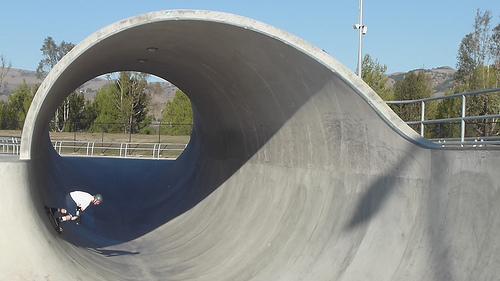How many people are there?
Give a very brief answer. 1. 